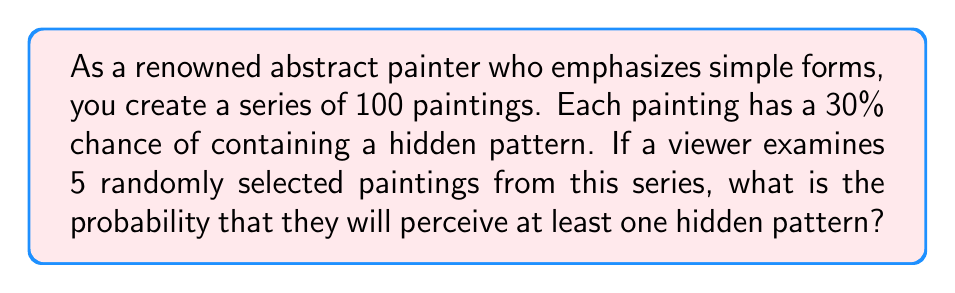Give your solution to this math problem. To solve this problem, we'll use the complement method:

1) First, let's calculate the probability of not perceiving a hidden pattern in a single painting:
   $P(\text{no hidden pattern}) = 1 - P(\text{hidden pattern}) = 1 - 0.30 = 0.70$

2) For the viewer to not perceive any hidden patterns in 5 paintings, this needs to happen 5 times in a row. Since the paintings are selected randomly and independently, we can multiply these probabilities:
   $P(\text{no hidden patterns in 5 paintings}) = 0.70^5 = 0.16807$

3) Now, the probability of perceiving at least one hidden pattern is the complement of not perceiving any:
   $P(\text{at least one hidden pattern}) = 1 - P(\text{no hidden patterns in 5 paintings})$
   $= 1 - 0.16807 = 0.83193$

4) Converting to a percentage:
   $0.83193 \times 100\% = 83.193\%$

Therefore, the probability that a viewer will perceive at least one hidden pattern when examining 5 randomly selected paintings is approximately 83.19%.
Answer: The probability is approximately 83.19%. 